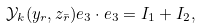<formula> <loc_0><loc_0><loc_500><loc_500>\mathcal { Y } _ { k } ( y _ { r } , z _ { \bar { r } } ) e _ { 3 } \cdot e _ { 3 } = I _ { 1 } + I _ { 2 } ,</formula> 